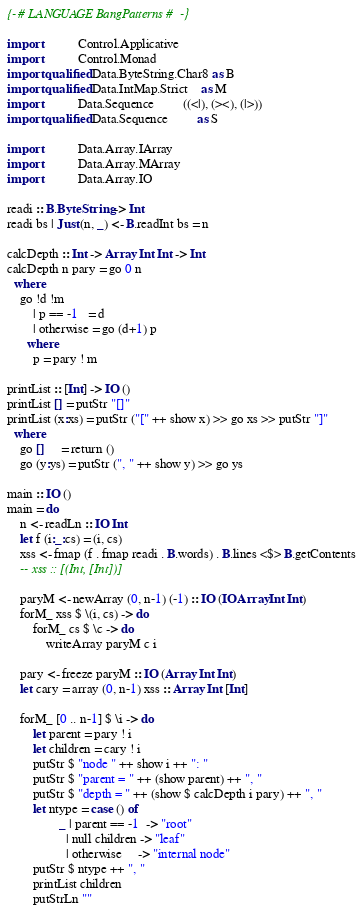Convert code to text. <code><loc_0><loc_0><loc_500><loc_500><_Haskell_>{-# LANGUAGE BangPatterns #-}

import           Control.Applicative
import           Control.Monad
import qualified Data.ByteString.Char8 as B
import qualified Data.IntMap.Strict    as M
import           Data.Sequence         ((<|), (><), (|>))
import qualified Data.Sequence         as S

import           Data.Array.IArray
import           Data.Array.MArray
import           Data.Array.IO

readi :: B.ByteString -> Int
readi bs | Just (n, _) <- B.readInt bs = n

calcDepth :: Int -> Array Int Int -> Int
calcDepth n pary = go 0 n
  where
    go !d !m
        | p == -1   = d
        | otherwise = go (d+1) p
      where
        p = pary ! m

printList :: [Int] -> IO ()
printList [] = putStr "[]"
printList (x:xs) = putStr ("[" ++ show x) >> go xs >> putStr "]"
  where
    go []     = return ()
    go (y:ys) = putStr (", " ++ show y) >> go ys

main :: IO ()
main = do
    n <- readLn :: IO Int
    let f (i:_:cs) = (i, cs)
    xss <- fmap (f . fmap readi . B.words) . B.lines <$> B.getContents
    -- xss :: [(Int, [Int])]

    paryM <- newArray (0, n-1) (-1) :: IO (IOArray Int Int)
    forM_ xss $ \(i, cs) -> do
        forM_ cs $ \c -> do
            writeArray paryM c i

    pary <- freeze paryM :: IO (Array Int Int)
    let cary = array (0, n-1) xss :: Array Int [Int]

    forM_ [0 .. n-1] $ \i -> do
        let parent = pary ! i
        let children = cary ! i
        putStr $ "node " ++ show i ++ ": "
        putStr $ "parent = " ++ (show parent) ++ ", "
        putStr $ "depth = " ++ (show $ calcDepth i pary) ++ ", "
        let ntype = case () of
                _ | parent == -1  -> "root"
                  | null children -> "leaf"
                  | otherwise     -> "internal node"
        putStr $ ntype ++ ", "
        printList children
        putStrLn ""

</code> 